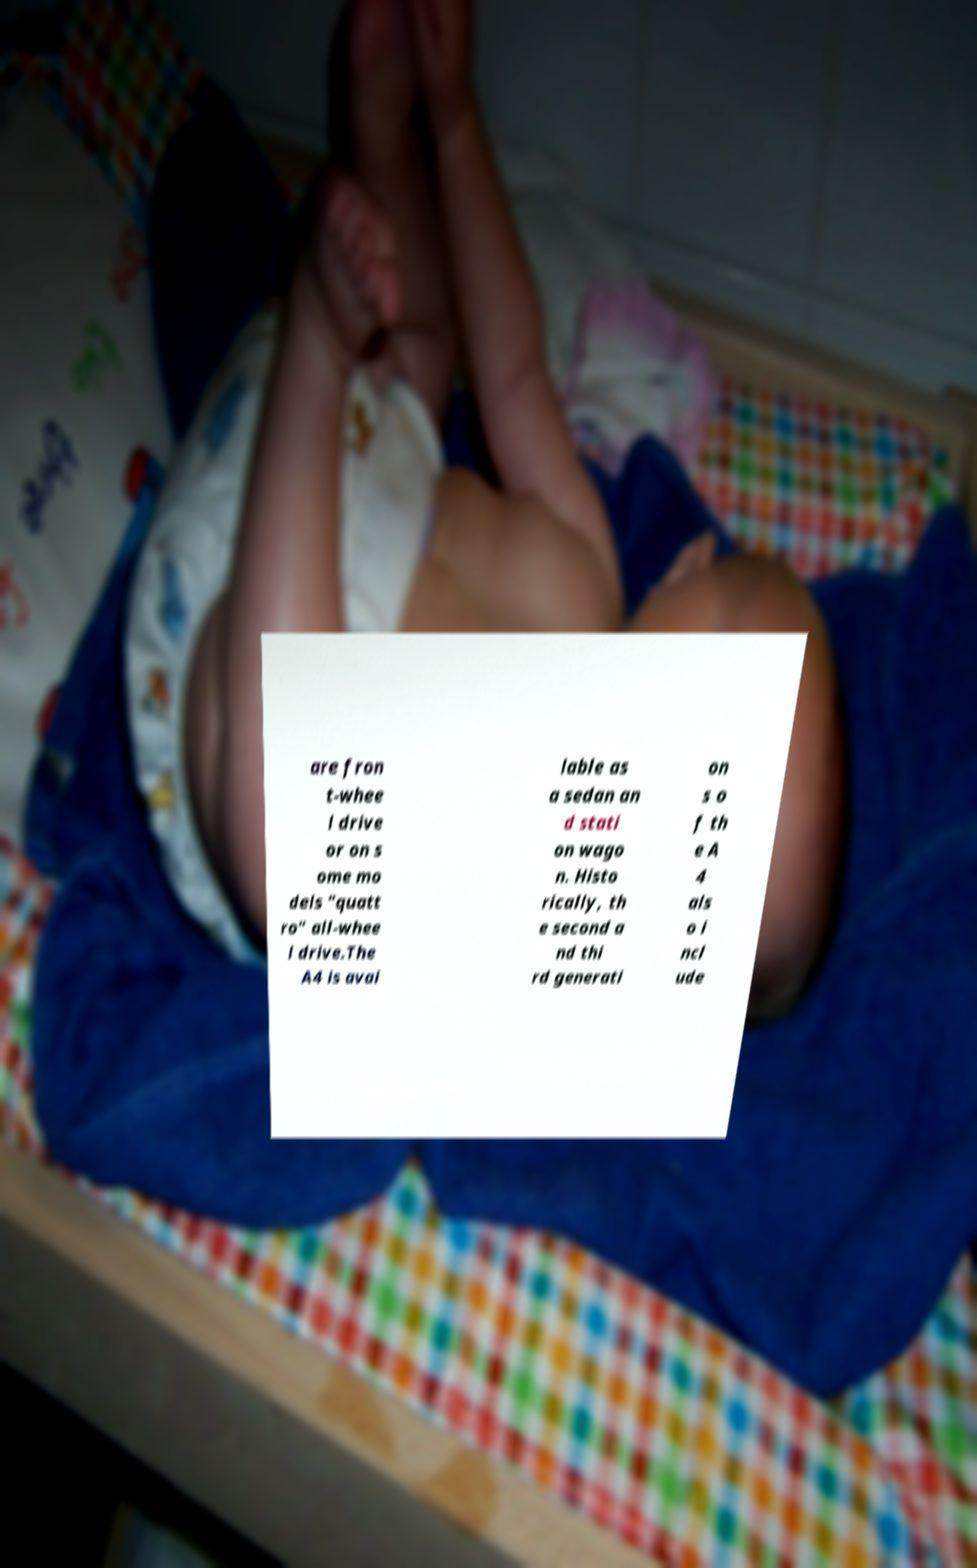Please identify and transcribe the text found in this image. are fron t-whee l drive or on s ome mo dels "quatt ro" all-whee l drive.The A4 is avai lable as a sedan an d stati on wago n. Histo rically, th e second a nd thi rd generati on s o f th e A 4 als o i ncl ude 